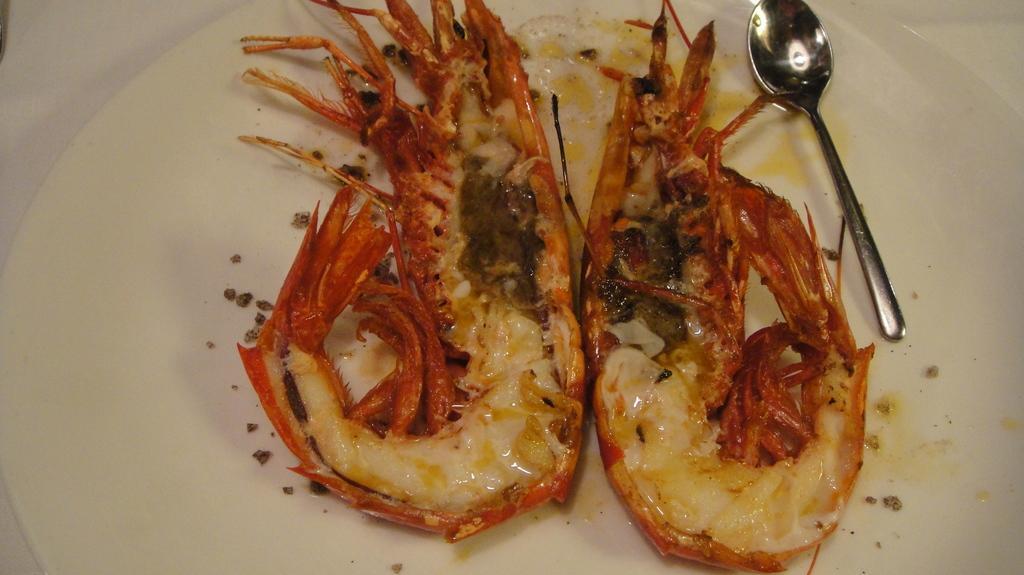Describe this image in one or two sentences. In this image I can see a white colour plate and in it I can see a spoon and food. 